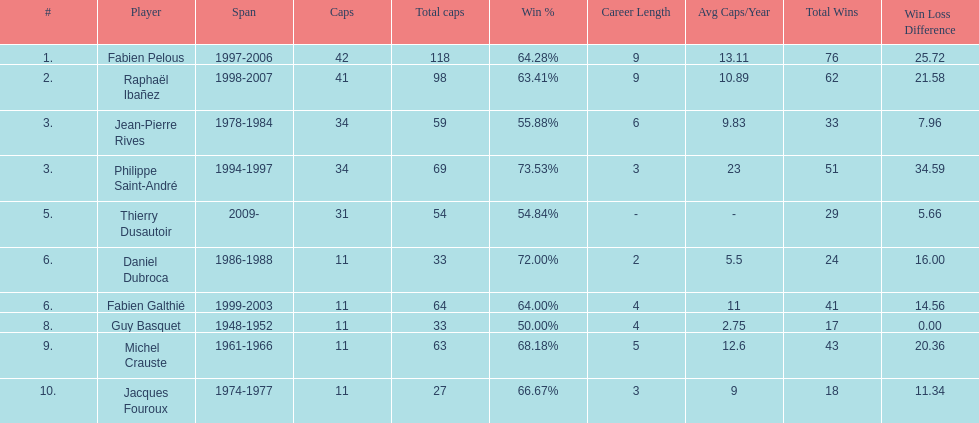I'm looking to parse the entire table for insights. Could you assist me with that? {'header': ['#', 'Player', 'Span', 'Caps', 'Total caps', 'Win\xa0%', 'Career Length', 'Avg Caps/Year', 'Total Wins', 'Win Loss Difference'], 'rows': [['1.', 'Fabien Pelous', '1997-2006', '42', '118', '64.28%', '9', '13.11', '76', '25.72'], ['2.', 'Raphaël Ibañez', '1998-2007', '41', '98', '63.41%', '9', '10.89', '62', '21.58'], ['3.', 'Jean-Pierre Rives', '1978-1984', '34', '59', '55.88%', '6', '9.83', '33', '7.96'], ['3.', 'Philippe Saint-André', '1994-1997', '34', '69', '73.53%', '3', '23', '51', '34.59'], ['5.', 'Thierry Dusautoir', '2009-', '31', '54', '54.84%', '-', '-', '29', '5.66'], ['6.', 'Daniel Dubroca', '1986-1988', '11', '33', '72.00%', '2', '5.5', '24', '16.00'], ['6.', 'Fabien Galthié', '1999-2003', '11', '64', '64.00%', '4', '11', '41', '14.56'], ['8.', 'Guy Basquet', '1948-1952', '11', '33', '50.00%', '4', '2.75', '17', '0.00'], ['9.', 'Michel Crauste', '1961-1966', '11', '63', '68.18%', '5', '12.6', '43', '20.36'], ['10.', 'Jacques Fouroux', '1974-1977', '11', '27', '66.67%', '3', '9', '18', '11.34']]} For what duration was michel crauste the captain? 1961-1966. 